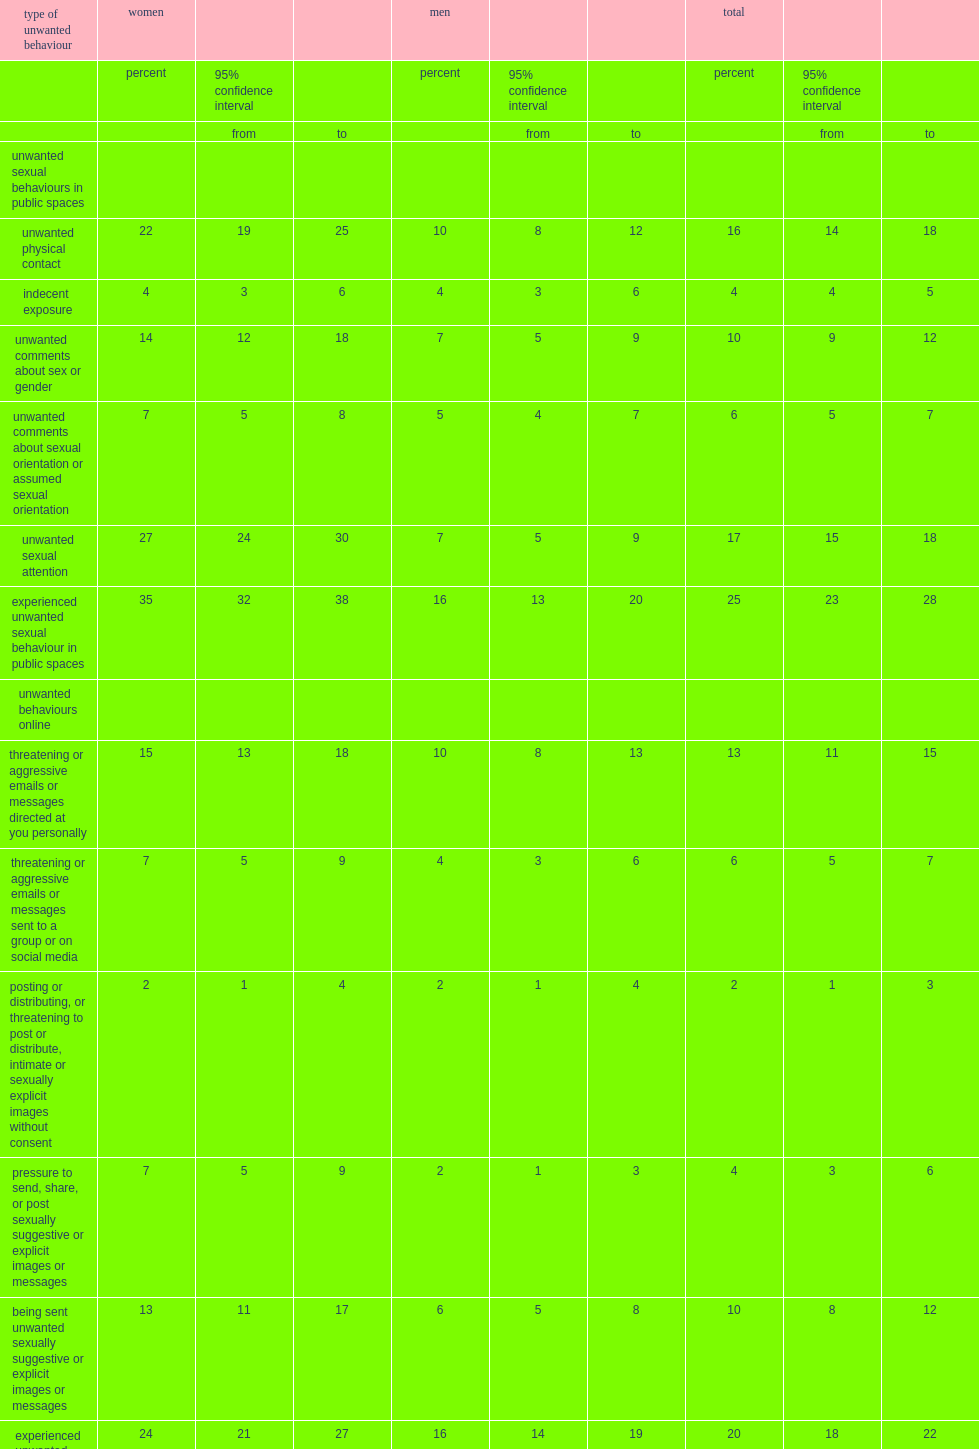Which two are the most common unwanted behaviours online cited by total respondents? Threatening or aggressive emails or messages directed at you personally being sent unwanted sexually suggestive or explicit images or messages. What is the percentage of total repondents who reported that their unwanted behaviour online was someone had published or threatened to publish intimate or sexually explicit images without their consent? 2.0. What is the percentage of women who were targets of at least one of the unwanted behaviour online measured by the sspps? 24.0. What is the percentage of men who were targets of at least one of the unwanted behaviour online measured by the sspps? 16.0. What is the percentage of women who were directly targeted with at least one inappropriate sexual behaviour in the workplace? 31.0. What is the percentage of men who reported they had experienced inappropriate sexual behaviour in the workplace? 16.0. What is the percentage of women who reported being subjected to unwanted sexual attention, such as whistles, calls, suggestive looks, gestures or body language? 17.0. What is the percentage of men who reported being subjected to unwanted sexual attention, such as whistles, calls, suggestive looks, gestures or body language? 2.0. 